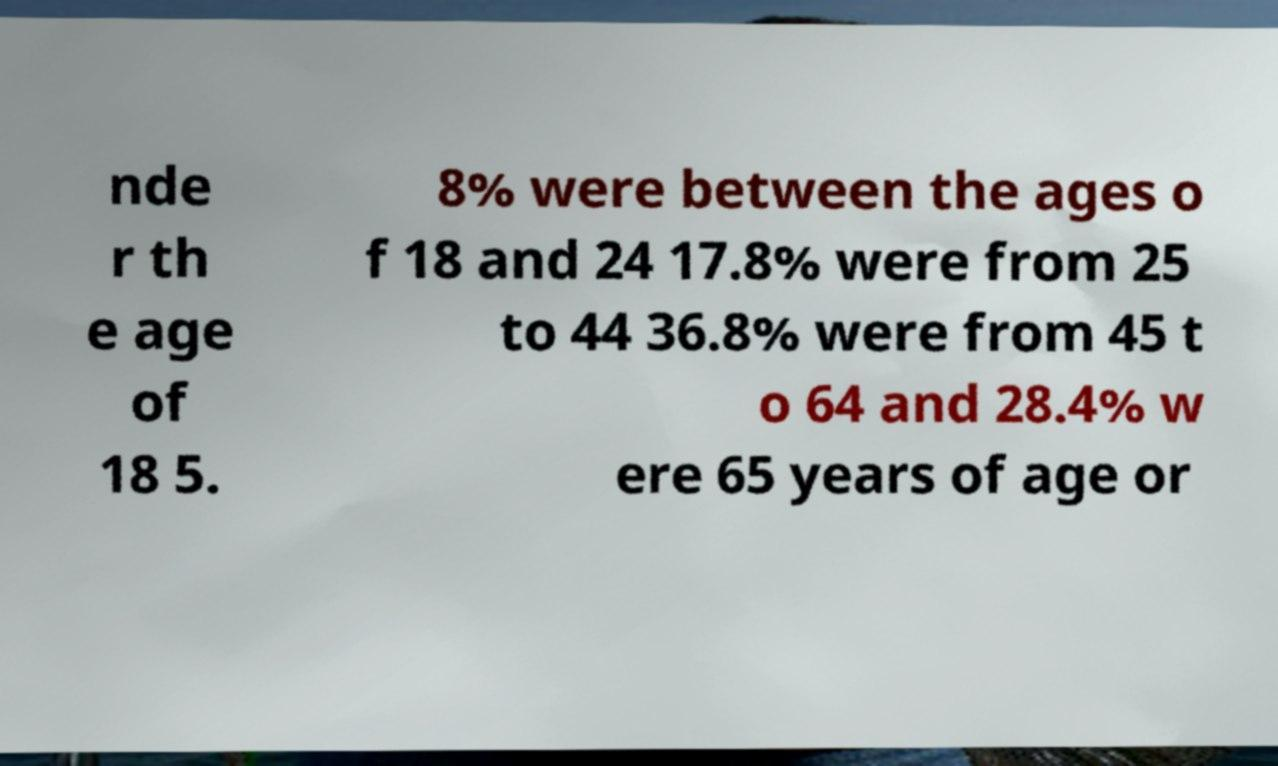Please read and relay the text visible in this image. What does it say? nde r th e age of 18 5. 8% were between the ages o f 18 and 24 17.8% were from 25 to 44 36.8% were from 45 t o 64 and 28.4% w ere 65 years of age or 